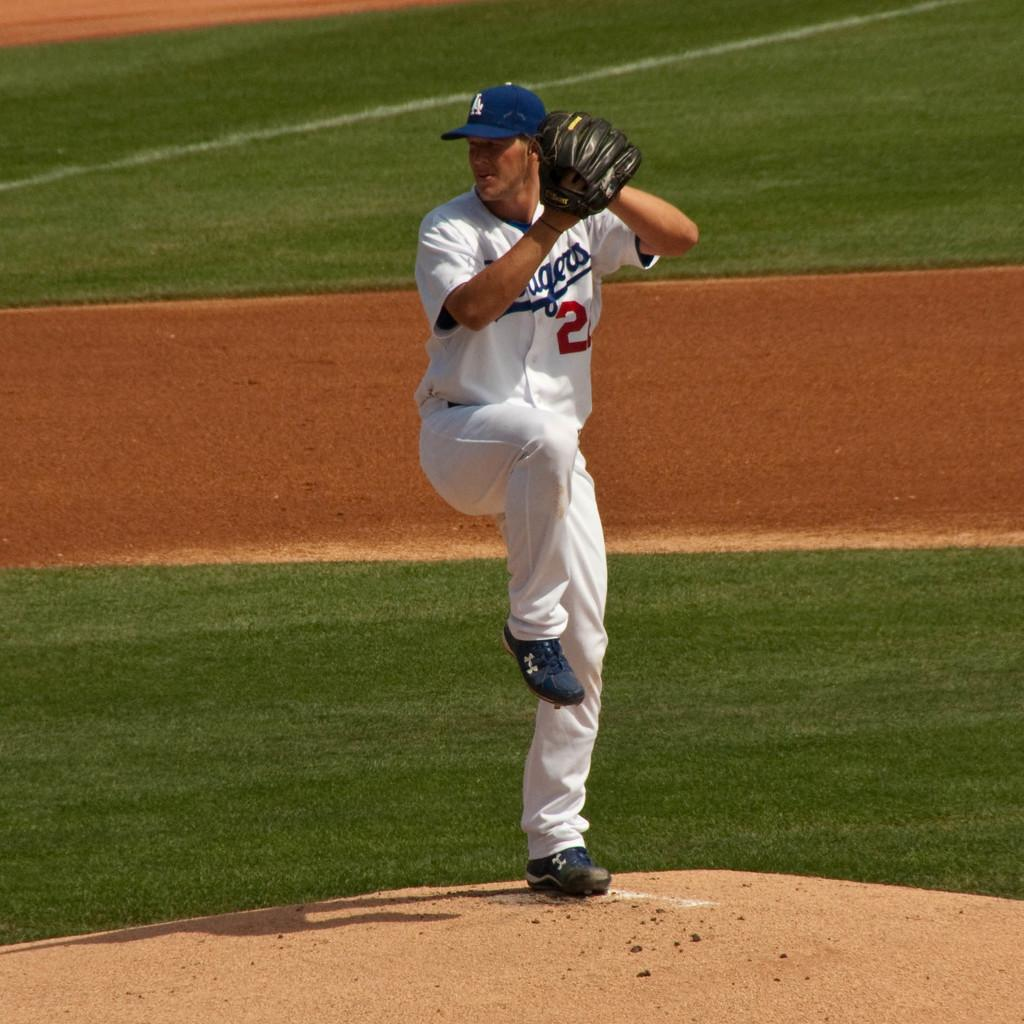<image>
Relay a brief, clear account of the picture shown. A baseball pitcher reading to throw wearing an LA hat 